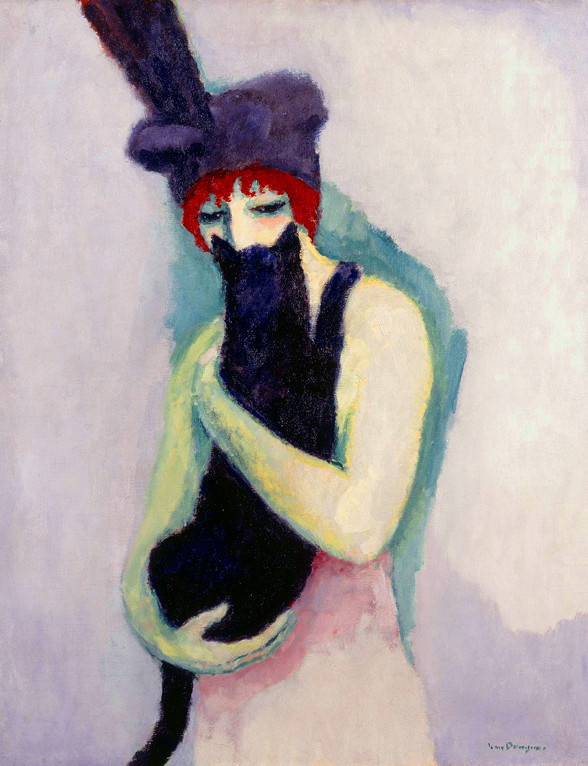What do you think is going on in this snapshot? The image portrays a woman in a post-impressionist style, characterized by its vibrant and emotive use of color. She holds a black cat suggestively, creating a visual narrative of companionship and serenity. Her red hat, adorned with a feather, and a draped green shawl offer a sharp contrast to the subdued purple background, possibly suggesting a subtle state of contemplation or solitude. Additionally, the stylistic choice invites interpretations centered on the emotional or psychological state of the woman, intensified by her gaze and the manner in which she cradles the cat. This artwork may aim to evoke feelings of comfort or introspection, highlighting the intimate bond between human and animal. 